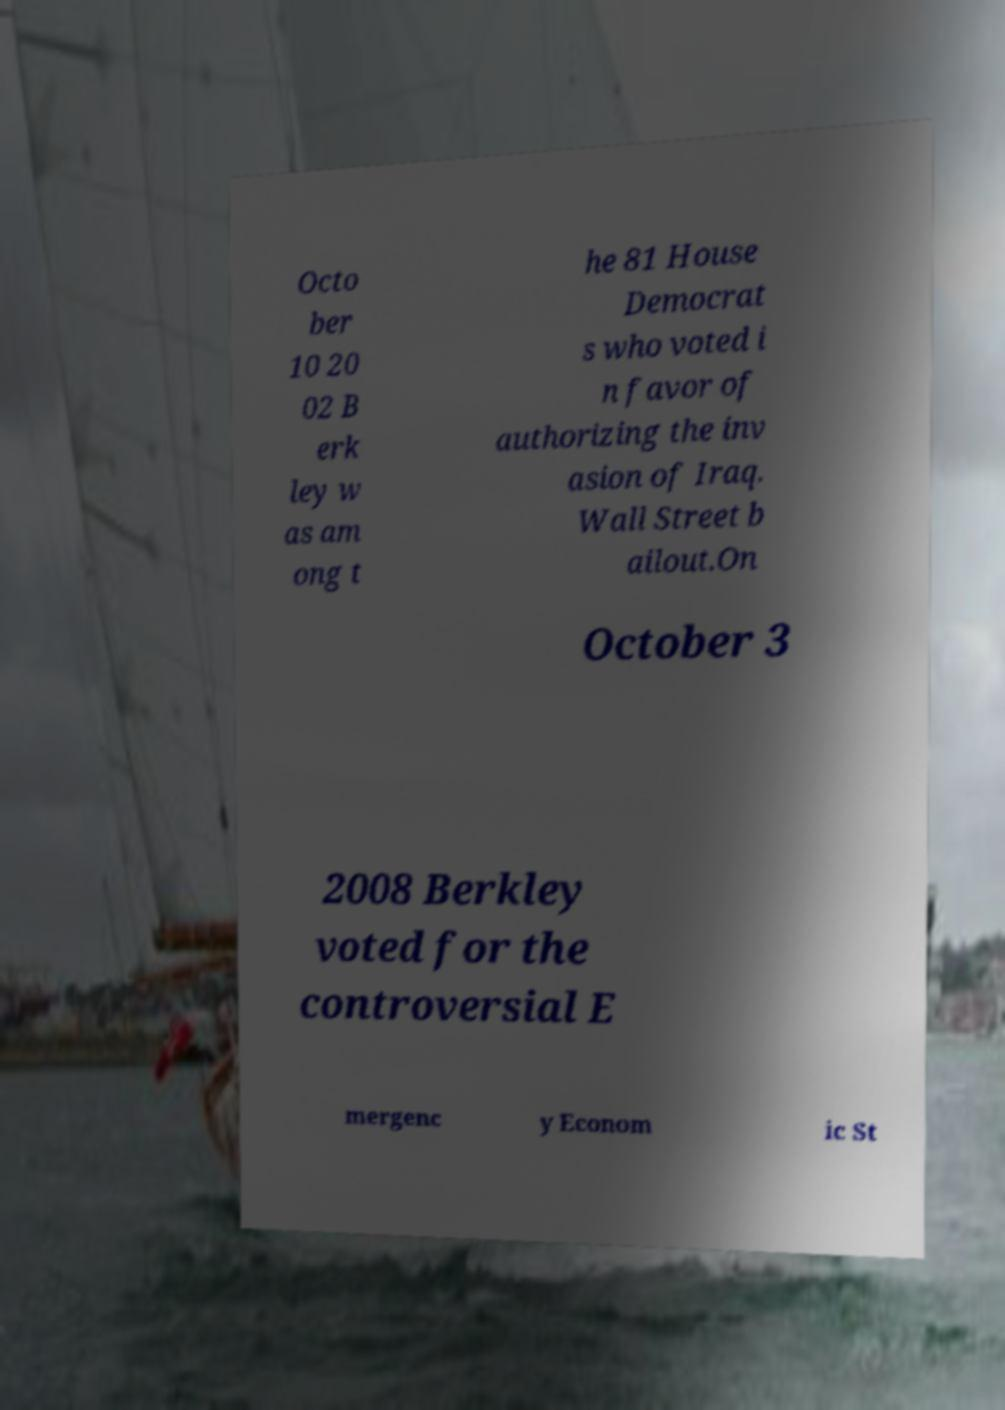There's text embedded in this image that I need extracted. Can you transcribe it verbatim? Octo ber 10 20 02 B erk ley w as am ong t he 81 House Democrat s who voted i n favor of authorizing the inv asion of Iraq. Wall Street b ailout.On October 3 2008 Berkley voted for the controversial E mergenc y Econom ic St 